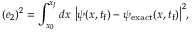Convert formula to latex. <formula><loc_0><loc_0><loc_500><loc_500>( e _ { 2 } ) ^ { 2 } = \int _ { x _ { 0 } } ^ { x _ { J } } d x \ \left | \psi ( x , t _ { f } ) - \psi _ { e x a c t } ( x , t _ { f } ) \right | ^ { 2 } ,</formula> 